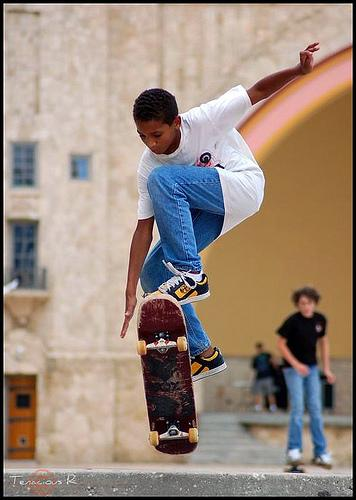In a short sentence, describe the young boy's appearance and his main action in the image. The short-haired, black-haired boy in casual attire effortlessly executes a trick on a multi-colored skateboard. What is the boy in the picture wearing and what object is he interacting with? The boy is wearing a white tee shirt, blue jeans, and white tennis shoes, and he is on a skateboard with faded red paint. In just one sentence, tell me what the boy in the image looks like and what action he is performing. The short black-haired boy is wearing casual clothes and performing a trick on a colorful skateboard. Write a brief sentence describing the boy in the image and his main activity. A young boy with short black hair is doing a trick on a red skateboard with yellow wheels. Explain what the boy in the picture is doing and the type of skateboard he is using. The boy is jumping on a skate board with faded red paint while wearing a white shirt and blue jeans. Briefly describe the boy's clothing and the object he is interacting with in the image. Boy in a white tee shirt, blue jeans, and white tennis shoes is riding a skateboard with yellow and blue wheels. Using concise language, describe the boy's appearance and the activity he is engaged in. Short-haired boy in white shirt and blue jeans, skillfully riding a red and blue skateboard. Mention the appearance and activity of the main subject in the image in one sentence. The young boy donning a white shirt and blue jeans masterfully performs a trick on his red skateboard. Provide a short description of the main subject's outfit and the action they are involved in. Young boy in white tee, blue jeans, and tennis shoes does a skateboard trick with style. Describe the person in the image and the object they are using for an activity. The image features a young boy with black hair, wearing casual clothing, and employing a skateboard with tan wheels for his trick. 